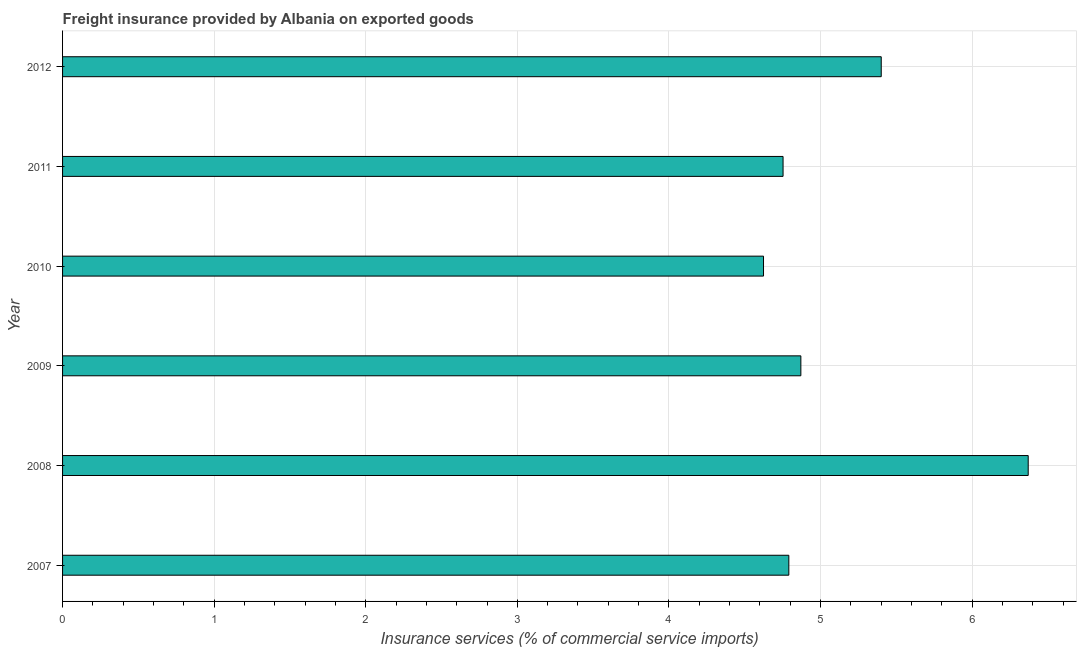Does the graph contain any zero values?
Ensure brevity in your answer.  No. Does the graph contain grids?
Offer a terse response. Yes. What is the title of the graph?
Offer a terse response. Freight insurance provided by Albania on exported goods . What is the label or title of the X-axis?
Offer a very short reply. Insurance services (% of commercial service imports). What is the label or title of the Y-axis?
Offer a very short reply. Year. What is the freight insurance in 2012?
Provide a succinct answer. 5.4. Across all years, what is the maximum freight insurance?
Make the answer very short. 6.37. Across all years, what is the minimum freight insurance?
Give a very brief answer. 4.62. In which year was the freight insurance maximum?
Provide a succinct answer. 2008. In which year was the freight insurance minimum?
Your answer should be compact. 2010. What is the sum of the freight insurance?
Your answer should be compact. 30.81. What is the difference between the freight insurance in 2009 and 2010?
Your answer should be compact. 0.25. What is the average freight insurance per year?
Ensure brevity in your answer.  5.13. What is the median freight insurance?
Your answer should be compact. 4.83. Is the sum of the freight insurance in 2010 and 2011 greater than the maximum freight insurance across all years?
Offer a very short reply. Yes. What is the difference between the highest and the lowest freight insurance?
Keep it short and to the point. 1.75. In how many years, is the freight insurance greater than the average freight insurance taken over all years?
Your answer should be compact. 2. How many bars are there?
Keep it short and to the point. 6. Are the values on the major ticks of X-axis written in scientific E-notation?
Provide a succinct answer. No. What is the Insurance services (% of commercial service imports) of 2007?
Offer a very short reply. 4.79. What is the Insurance services (% of commercial service imports) in 2008?
Your answer should be very brief. 6.37. What is the Insurance services (% of commercial service imports) of 2009?
Provide a succinct answer. 4.87. What is the Insurance services (% of commercial service imports) in 2010?
Ensure brevity in your answer.  4.62. What is the Insurance services (% of commercial service imports) of 2011?
Make the answer very short. 4.75. What is the Insurance services (% of commercial service imports) of 2012?
Your answer should be very brief. 5.4. What is the difference between the Insurance services (% of commercial service imports) in 2007 and 2008?
Make the answer very short. -1.58. What is the difference between the Insurance services (% of commercial service imports) in 2007 and 2009?
Keep it short and to the point. -0.08. What is the difference between the Insurance services (% of commercial service imports) in 2007 and 2010?
Your response must be concise. 0.17. What is the difference between the Insurance services (% of commercial service imports) in 2007 and 2011?
Make the answer very short. 0.04. What is the difference between the Insurance services (% of commercial service imports) in 2007 and 2012?
Give a very brief answer. -0.61. What is the difference between the Insurance services (% of commercial service imports) in 2008 and 2009?
Your answer should be compact. 1.5. What is the difference between the Insurance services (% of commercial service imports) in 2008 and 2010?
Your answer should be very brief. 1.75. What is the difference between the Insurance services (% of commercial service imports) in 2008 and 2011?
Make the answer very short. 1.62. What is the difference between the Insurance services (% of commercial service imports) in 2008 and 2012?
Ensure brevity in your answer.  0.97. What is the difference between the Insurance services (% of commercial service imports) in 2009 and 2010?
Give a very brief answer. 0.25. What is the difference between the Insurance services (% of commercial service imports) in 2009 and 2011?
Provide a succinct answer. 0.12. What is the difference between the Insurance services (% of commercial service imports) in 2009 and 2012?
Your answer should be compact. -0.53. What is the difference between the Insurance services (% of commercial service imports) in 2010 and 2011?
Provide a succinct answer. -0.13. What is the difference between the Insurance services (% of commercial service imports) in 2010 and 2012?
Provide a short and direct response. -0.78. What is the difference between the Insurance services (% of commercial service imports) in 2011 and 2012?
Your response must be concise. -0.65. What is the ratio of the Insurance services (% of commercial service imports) in 2007 to that in 2008?
Ensure brevity in your answer.  0.75. What is the ratio of the Insurance services (% of commercial service imports) in 2007 to that in 2009?
Offer a terse response. 0.98. What is the ratio of the Insurance services (% of commercial service imports) in 2007 to that in 2010?
Your answer should be very brief. 1.04. What is the ratio of the Insurance services (% of commercial service imports) in 2007 to that in 2012?
Keep it short and to the point. 0.89. What is the ratio of the Insurance services (% of commercial service imports) in 2008 to that in 2009?
Provide a succinct answer. 1.31. What is the ratio of the Insurance services (% of commercial service imports) in 2008 to that in 2010?
Give a very brief answer. 1.38. What is the ratio of the Insurance services (% of commercial service imports) in 2008 to that in 2011?
Keep it short and to the point. 1.34. What is the ratio of the Insurance services (% of commercial service imports) in 2008 to that in 2012?
Offer a terse response. 1.18. What is the ratio of the Insurance services (% of commercial service imports) in 2009 to that in 2010?
Give a very brief answer. 1.05. What is the ratio of the Insurance services (% of commercial service imports) in 2009 to that in 2012?
Your response must be concise. 0.9. What is the ratio of the Insurance services (% of commercial service imports) in 2010 to that in 2011?
Provide a short and direct response. 0.97. What is the ratio of the Insurance services (% of commercial service imports) in 2010 to that in 2012?
Offer a terse response. 0.86. 